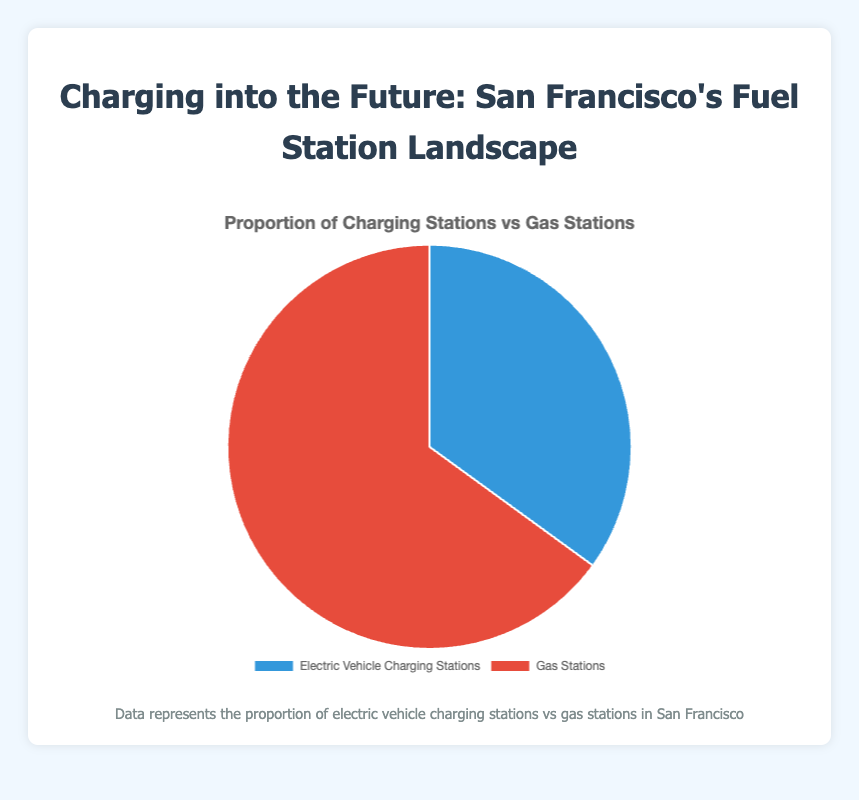What is the proportion of gas stations in San Francisco? The pie chart shows that gas stations make up 65% of the total stations.
Answer: 65% How many more gas stations are there compared to electric vehicle charging stations? The proportion of gas stations is 65% and electric vehicle charging stations is 35%. The difference is 65% - 35% = 30%.
Answer: 30% What percentage of the total stations are electric vehicle charging stations? The pie chart indicates that electric vehicle charging stations account for 35% of the total stations in San Francisco.
Answer: 35% Are electric vehicle charging stations less common than gas stations? Yes, the proportion of electric vehicle charging stations (35%) is less than that of gas stations (65%), as indicated by the pie chart.
Answer: Yes What is the ratio of electric vehicle charging stations to gas stations? The ratio can be calculated by dividing the proportion of electric vehicle charging stations (35%) by the proportion of gas stations (65%): 35 / 65 = 0.5385 ≈ 0.54.
Answer: 0.54 What is the sum of the proportions of electric vehicle charging stations and gas stations? Adding the proportions of electric vehicle charging stations (35%) and gas stations (65%) gives a total of 35% + 65% = 100%.
Answer: 100% Which segment has the blue color in the pie chart? The segment representing electric vehicle charging stations is colored blue, as indicated in the chart legend.
Answer: Electric Vehicle Charging Stations If San Francisco decided to add more electric vehicle charging stations, what would you expect to happen to the size of the blue segment in the chart? Adding more electric vehicle charging stations would increase their proportion, making the blue segment larger in the pie chart.
Answer: Increase 